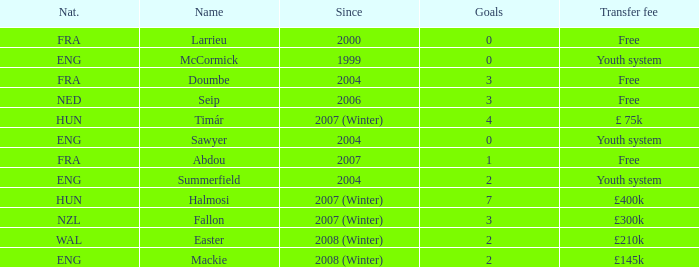What is the nationality of the player with a transfer fee of £400k? HUN. 